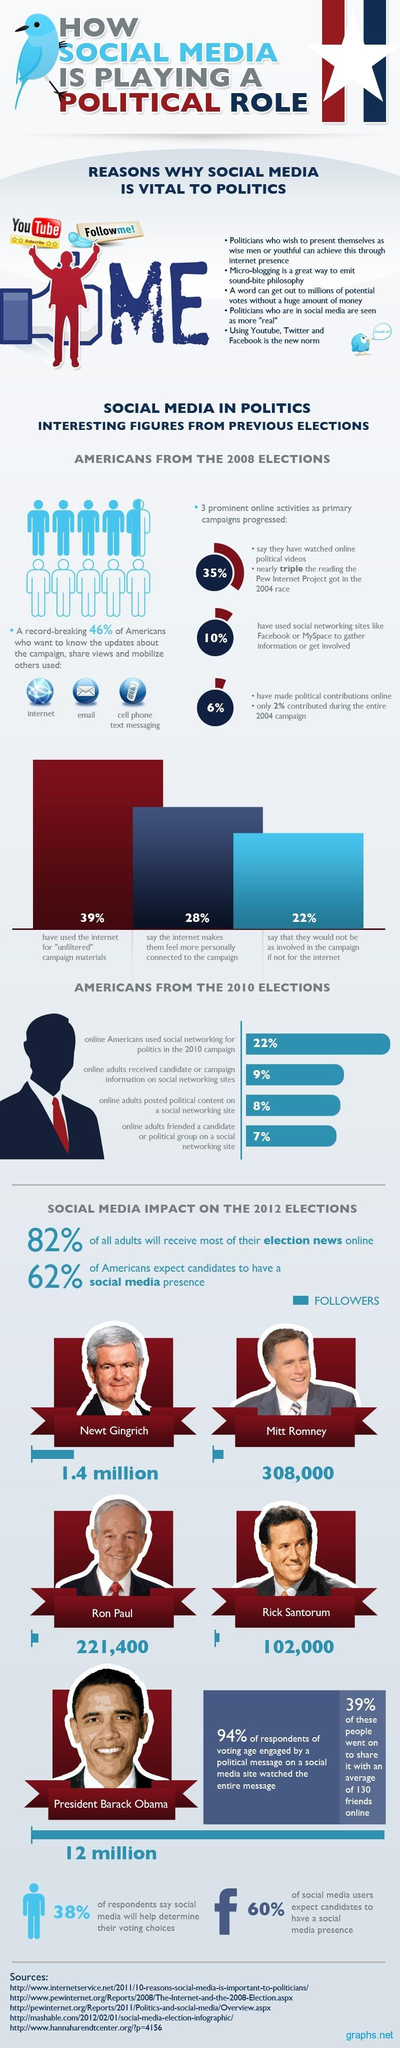Identify some key points in this picture. According to a recent survey, approximately 90% of Americans have not used social networking sites to gather information or become involved in the 2008 US elections. Ron Paul had 221,400 social media followers during the 2012 US elections. According to a survey conducted in 2012, 40% of social media users did not expect the candidates in the US elections to have a social media presence. Barack Obama had the highest number of social media followers during the 2012 US presidential campaign. During the 2012 US elections, Mitt Romney had a total of 308,000 social media followers. 